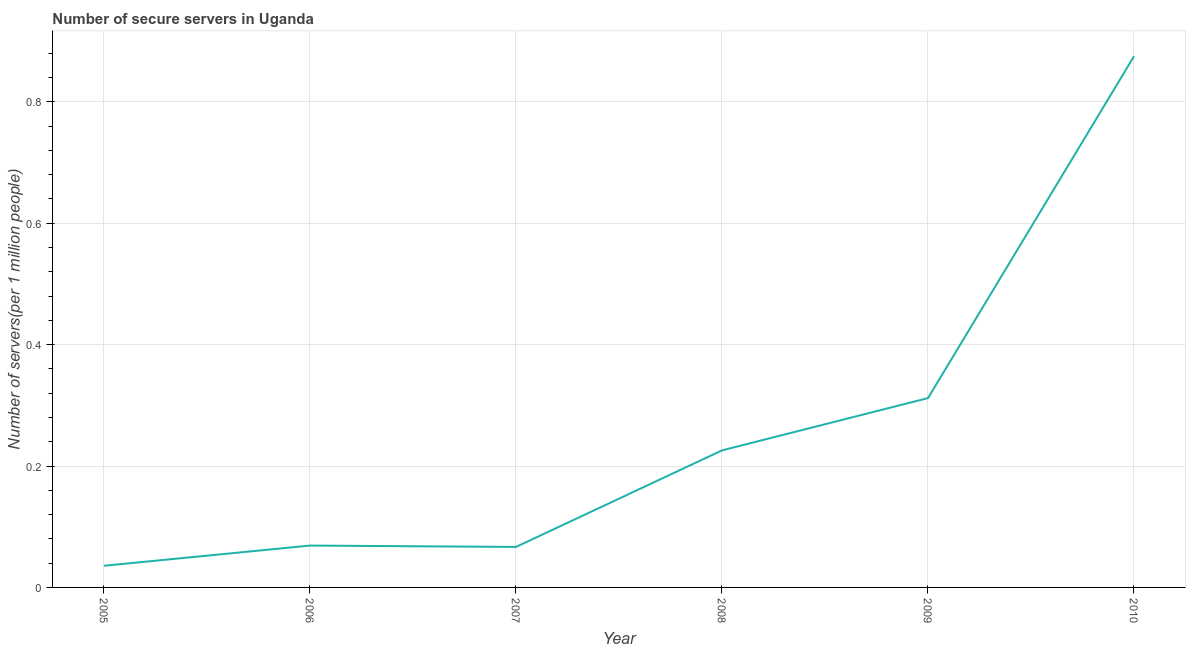What is the number of secure internet servers in 2009?
Provide a succinct answer. 0.31. Across all years, what is the maximum number of secure internet servers?
Offer a terse response. 0.87. Across all years, what is the minimum number of secure internet servers?
Ensure brevity in your answer.  0.04. In which year was the number of secure internet servers maximum?
Ensure brevity in your answer.  2010. What is the sum of the number of secure internet servers?
Provide a succinct answer. 1.58. What is the difference between the number of secure internet servers in 2005 and 2010?
Provide a succinct answer. -0.84. What is the average number of secure internet servers per year?
Provide a succinct answer. 0.26. What is the median number of secure internet servers?
Provide a short and direct response. 0.15. Do a majority of the years between 2009 and 2006 (inclusive) have number of secure internet servers greater than 0.8400000000000001 ?
Ensure brevity in your answer.  Yes. What is the ratio of the number of secure internet servers in 2008 to that in 2010?
Provide a short and direct response. 0.26. Is the difference between the number of secure internet servers in 2005 and 2009 greater than the difference between any two years?
Give a very brief answer. No. What is the difference between the highest and the second highest number of secure internet servers?
Provide a short and direct response. 0.56. What is the difference between the highest and the lowest number of secure internet servers?
Offer a terse response. 0.84. In how many years, is the number of secure internet servers greater than the average number of secure internet servers taken over all years?
Keep it short and to the point. 2. What is the difference between two consecutive major ticks on the Y-axis?
Give a very brief answer. 0.2. Are the values on the major ticks of Y-axis written in scientific E-notation?
Provide a succinct answer. No. Does the graph contain any zero values?
Ensure brevity in your answer.  No. Does the graph contain grids?
Provide a succinct answer. Yes. What is the title of the graph?
Ensure brevity in your answer.  Number of secure servers in Uganda. What is the label or title of the X-axis?
Keep it short and to the point. Year. What is the label or title of the Y-axis?
Ensure brevity in your answer.  Number of servers(per 1 million people). What is the Number of servers(per 1 million people) of 2005?
Your answer should be compact. 0.04. What is the Number of servers(per 1 million people) in 2006?
Keep it short and to the point. 0.07. What is the Number of servers(per 1 million people) in 2007?
Your response must be concise. 0.07. What is the Number of servers(per 1 million people) in 2008?
Offer a terse response. 0.23. What is the Number of servers(per 1 million people) of 2009?
Offer a very short reply. 0.31. What is the Number of servers(per 1 million people) in 2010?
Give a very brief answer. 0.87. What is the difference between the Number of servers(per 1 million people) in 2005 and 2006?
Offer a terse response. -0.03. What is the difference between the Number of servers(per 1 million people) in 2005 and 2007?
Your answer should be compact. -0.03. What is the difference between the Number of servers(per 1 million people) in 2005 and 2008?
Give a very brief answer. -0.19. What is the difference between the Number of servers(per 1 million people) in 2005 and 2009?
Make the answer very short. -0.28. What is the difference between the Number of servers(per 1 million people) in 2005 and 2010?
Ensure brevity in your answer.  -0.84. What is the difference between the Number of servers(per 1 million people) in 2006 and 2007?
Keep it short and to the point. 0. What is the difference between the Number of servers(per 1 million people) in 2006 and 2008?
Your answer should be compact. -0.16. What is the difference between the Number of servers(per 1 million people) in 2006 and 2009?
Make the answer very short. -0.24. What is the difference between the Number of servers(per 1 million people) in 2006 and 2010?
Give a very brief answer. -0.81. What is the difference between the Number of servers(per 1 million people) in 2007 and 2008?
Offer a terse response. -0.16. What is the difference between the Number of servers(per 1 million people) in 2007 and 2009?
Ensure brevity in your answer.  -0.25. What is the difference between the Number of servers(per 1 million people) in 2007 and 2010?
Give a very brief answer. -0.81. What is the difference between the Number of servers(per 1 million people) in 2008 and 2009?
Give a very brief answer. -0.09. What is the difference between the Number of servers(per 1 million people) in 2008 and 2010?
Offer a terse response. -0.65. What is the difference between the Number of servers(per 1 million people) in 2009 and 2010?
Offer a terse response. -0.56. What is the ratio of the Number of servers(per 1 million people) in 2005 to that in 2006?
Your response must be concise. 0.52. What is the ratio of the Number of servers(per 1 million people) in 2005 to that in 2007?
Give a very brief answer. 0.54. What is the ratio of the Number of servers(per 1 million people) in 2005 to that in 2008?
Your response must be concise. 0.16. What is the ratio of the Number of servers(per 1 million people) in 2005 to that in 2009?
Give a very brief answer. 0.11. What is the ratio of the Number of servers(per 1 million people) in 2005 to that in 2010?
Offer a terse response. 0.04. What is the ratio of the Number of servers(per 1 million people) in 2006 to that in 2007?
Give a very brief answer. 1.03. What is the ratio of the Number of servers(per 1 million people) in 2006 to that in 2008?
Keep it short and to the point. 0.31. What is the ratio of the Number of servers(per 1 million people) in 2006 to that in 2009?
Your answer should be compact. 0.22. What is the ratio of the Number of servers(per 1 million people) in 2006 to that in 2010?
Offer a terse response. 0.08. What is the ratio of the Number of servers(per 1 million people) in 2007 to that in 2008?
Provide a short and direct response. 0.29. What is the ratio of the Number of servers(per 1 million people) in 2007 to that in 2009?
Your response must be concise. 0.21. What is the ratio of the Number of servers(per 1 million people) in 2007 to that in 2010?
Offer a terse response. 0.08. What is the ratio of the Number of servers(per 1 million people) in 2008 to that in 2009?
Provide a short and direct response. 0.72. What is the ratio of the Number of servers(per 1 million people) in 2008 to that in 2010?
Provide a short and direct response. 0.26. What is the ratio of the Number of servers(per 1 million people) in 2009 to that in 2010?
Provide a succinct answer. 0.36. 